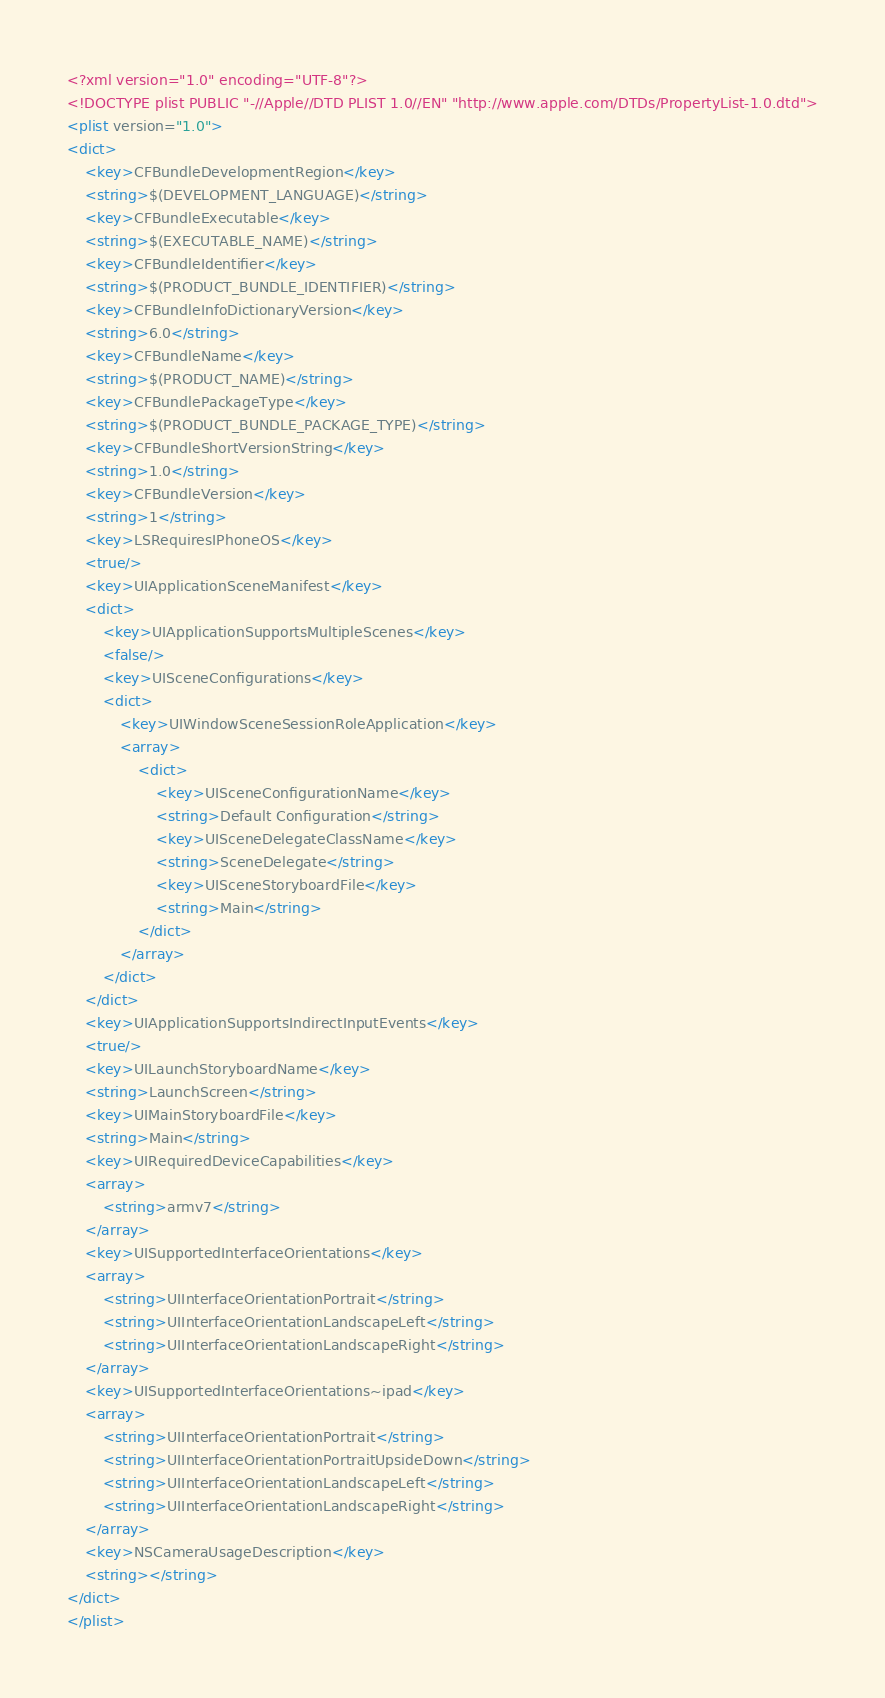<code> <loc_0><loc_0><loc_500><loc_500><_XML_><?xml version="1.0" encoding="UTF-8"?>
<!DOCTYPE plist PUBLIC "-//Apple//DTD PLIST 1.0//EN" "http://www.apple.com/DTDs/PropertyList-1.0.dtd">
<plist version="1.0">
<dict>
	<key>CFBundleDevelopmentRegion</key>
	<string>$(DEVELOPMENT_LANGUAGE)</string>
	<key>CFBundleExecutable</key>
	<string>$(EXECUTABLE_NAME)</string>
	<key>CFBundleIdentifier</key>
	<string>$(PRODUCT_BUNDLE_IDENTIFIER)</string>
	<key>CFBundleInfoDictionaryVersion</key>
	<string>6.0</string>
	<key>CFBundleName</key>
	<string>$(PRODUCT_NAME)</string>
	<key>CFBundlePackageType</key>
	<string>$(PRODUCT_BUNDLE_PACKAGE_TYPE)</string>
	<key>CFBundleShortVersionString</key>
	<string>1.0</string>
	<key>CFBundleVersion</key>
	<string>1</string>
	<key>LSRequiresIPhoneOS</key>
	<true/>
	<key>UIApplicationSceneManifest</key>
	<dict>
		<key>UIApplicationSupportsMultipleScenes</key>
		<false/>
		<key>UISceneConfigurations</key>
		<dict>
			<key>UIWindowSceneSessionRoleApplication</key>
			<array>
				<dict>
					<key>UISceneConfigurationName</key>
					<string>Default Configuration</string>
					<key>UISceneDelegateClassName</key>
					<string>SceneDelegate</string>
					<key>UISceneStoryboardFile</key>
					<string>Main</string>
				</dict>
			</array>
		</dict>
	</dict>
	<key>UIApplicationSupportsIndirectInputEvents</key>
	<true/>
	<key>UILaunchStoryboardName</key>
	<string>LaunchScreen</string>
	<key>UIMainStoryboardFile</key>
	<string>Main</string>
	<key>UIRequiredDeviceCapabilities</key>
	<array>
		<string>armv7</string>
	</array>
	<key>UISupportedInterfaceOrientations</key>
	<array>
		<string>UIInterfaceOrientationPortrait</string>
		<string>UIInterfaceOrientationLandscapeLeft</string>
		<string>UIInterfaceOrientationLandscapeRight</string>
	</array>
	<key>UISupportedInterfaceOrientations~ipad</key>
	<array>
		<string>UIInterfaceOrientationPortrait</string>
		<string>UIInterfaceOrientationPortraitUpsideDown</string>
		<string>UIInterfaceOrientationLandscapeLeft</string>
		<string>UIInterfaceOrientationLandscapeRight</string>
	</array>
	<key>NSCameraUsageDescription</key>
	<string></string>
</dict>
</plist>
</code> 